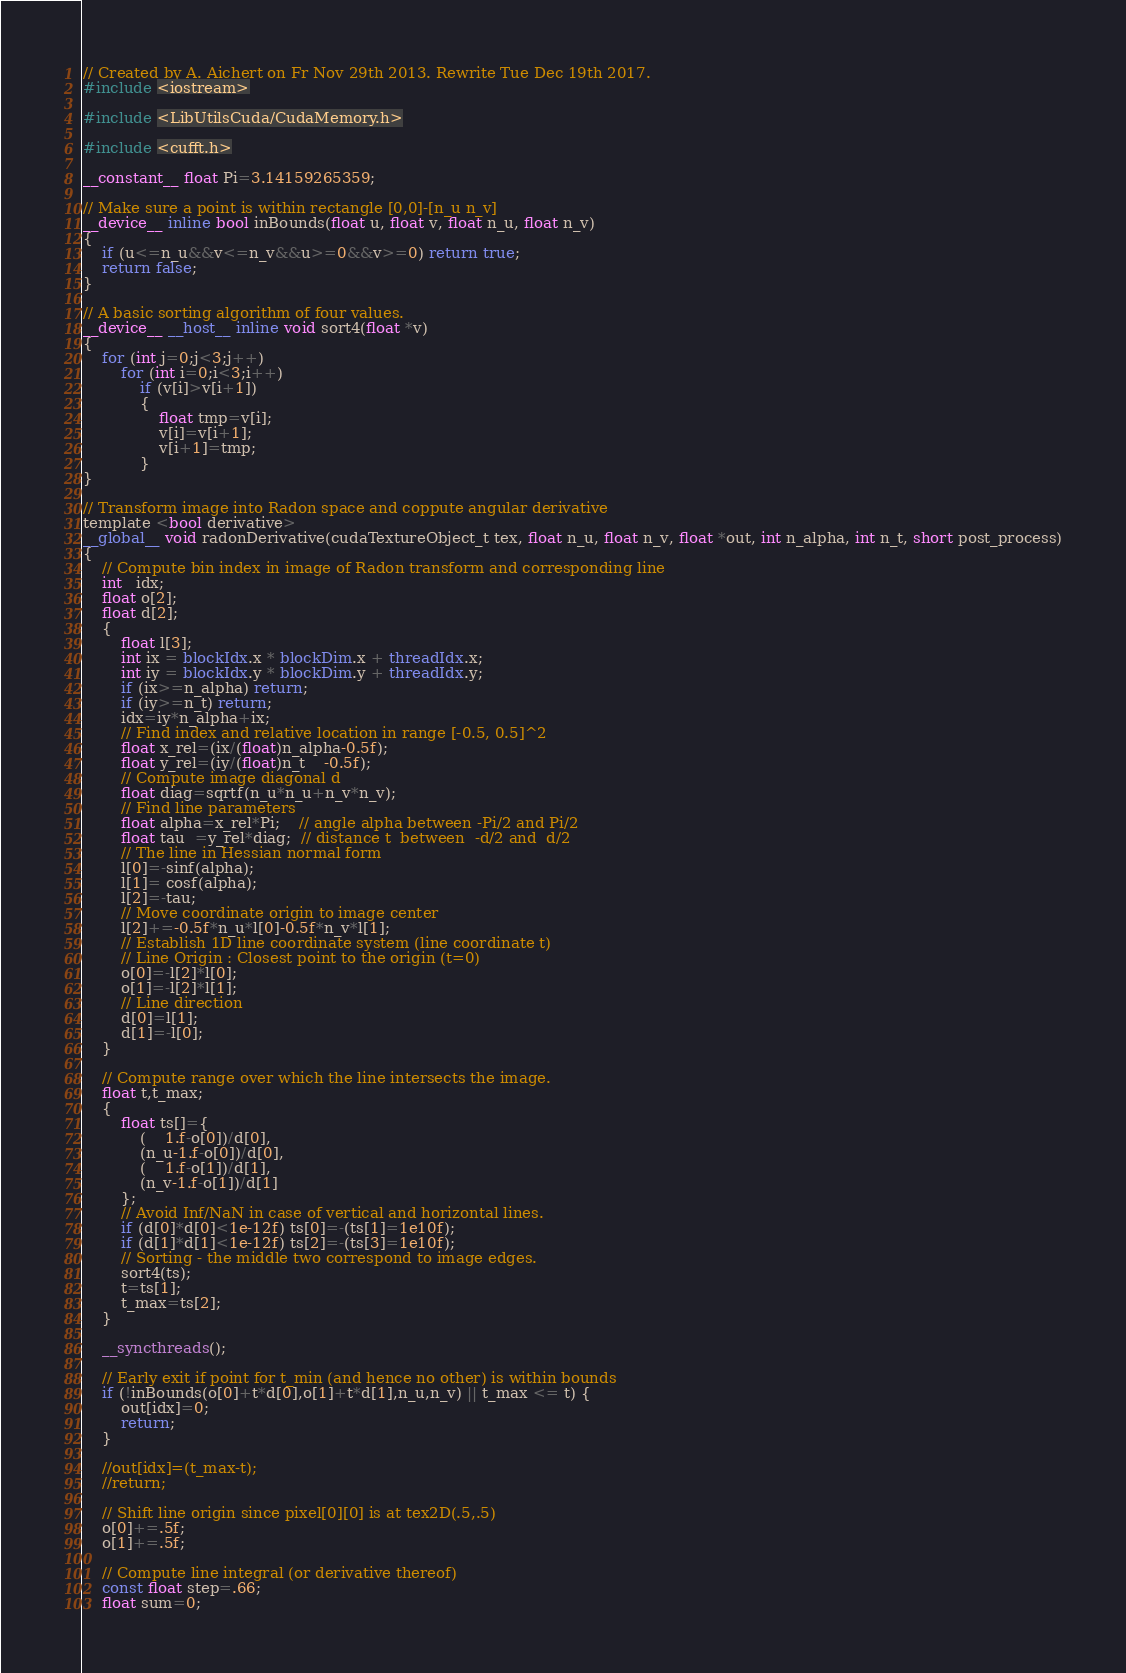Convert code to text. <code><loc_0><loc_0><loc_500><loc_500><_Cuda_>// Created by A. Aichert on Fr Nov 29th 2013. Rewrite Tue Dec 19th 2017.
#include <iostream>

#include <LibUtilsCuda/CudaMemory.h>

#include <cufft.h>

__constant__ float Pi=3.14159265359;

// Make sure a point is within rectangle [0,0]-[n_u n_v]
__device__ inline bool inBounds(float u, float v, float n_u, float n_v)
{
	if (u<=n_u&&v<=n_v&&u>=0&&v>=0) return true;
	return false;
}

// A basic sorting algorithm of four values.
__device__ __host__ inline void sort4(float *v)
{
	for (int j=0;j<3;j++)
		for (int i=0;i<3;i++)
			if (v[i]>v[i+1])
			{
				float tmp=v[i];
				v[i]=v[i+1];
				v[i+1]=tmp;
			}
}

// Transform image into Radon space and coppute angular derivative
template <bool derivative>
__global__ void radonDerivative(cudaTextureObject_t tex, float n_u, float n_v, float *out, int n_alpha, int n_t, short post_process)
{
	// Compute bin index in image of Radon transform and corresponding line
	int   idx;
	float o[2];
	float d[2];
	{
		float l[3];
		int ix = blockIdx.x * blockDim.x + threadIdx.x;
		int iy = blockIdx.y * blockDim.y + threadIdx.y;
		if (ix>=n_alpha) return;
		if (iy>=n_t) return;
		idx=iy*n_alpha+ix;
		// Find index and relative location in range [-0.5, 0.5]^2
		float x_rel=(ix/(float)n_alpha-0.5f);
		float y_rel=(iy/(float)n_t    -0.5f);
		// Compute image diagonal d
		float diag=sqrtf(n_u*n_u+n_v*n_v);
		// Find line parameters
		float alpha=x_rel*Pi;    // angle alpha between -Pi/2 and Pi/2
		float tau  =y_rel*diag;  // distance t  between  -d/2 and  d/2
		// The line in Hessian normal form
		l[0]=-sinf(alpha);
		l[1]= cosf(alpha);
		l[2]=-tau;
		// Move coordinate origin to image center
		l[2]+=-0.5f*n_u*l[0]-0.5f*n_v*l[1];
		// Establish 1D line coordinate system (line coordinate t)
		// Line Origin : Closest point to the origin (t=0)
		o[0]=-l[2]*l[0];
		o[1]=-l[2]*l[1];
		// Line direction
		d[0]=l[1];
		d[1]=-l[0];
	}

	// Compute range over which the line intersects the image.
	float t,t_max;
	{
		float ts[]={
			(    1.f-o[0])/d[0],
			(n_u-1.f-o[0])/d[0],
			(    1.f-o[1])/d[1],
			(n_v-1.f-o[1])/d[1]
		};
		// Avoid Inf/NaN in case of vertical and horizontal lines.
		if (d[0]*d[0]<1e-12f) ts[0]=-(ts[1]=1e10f);
		if (d[1]*d[1]<1e-12f) ts[2]=-(ts[3]=1e10f);
		// Sorting - the middle two correspond to image edges.
		sort4(ts);
		t=ts[1];
		t_max=ts[2];		
	}

	__syncthreads();

	// Early exit if point for t_min (and hence no other) is within bounds
	if (!inBounds(o[0]+t*d[0],o[1]+t*d[1],n_u,n_v) || t_max <= t) {
		out[idx]=0;
		return;
	}

	//out[idx]=(t_max-t);
	//return;

	// Shift line origin since pixel[0][0] is at tex2D(.5,.5)
	o[0]+=.5f;
	o[1]+=.5f;

	// Compute line integral (or derivative thereof)
	const float step=.66;
	float sum=0;</code> 